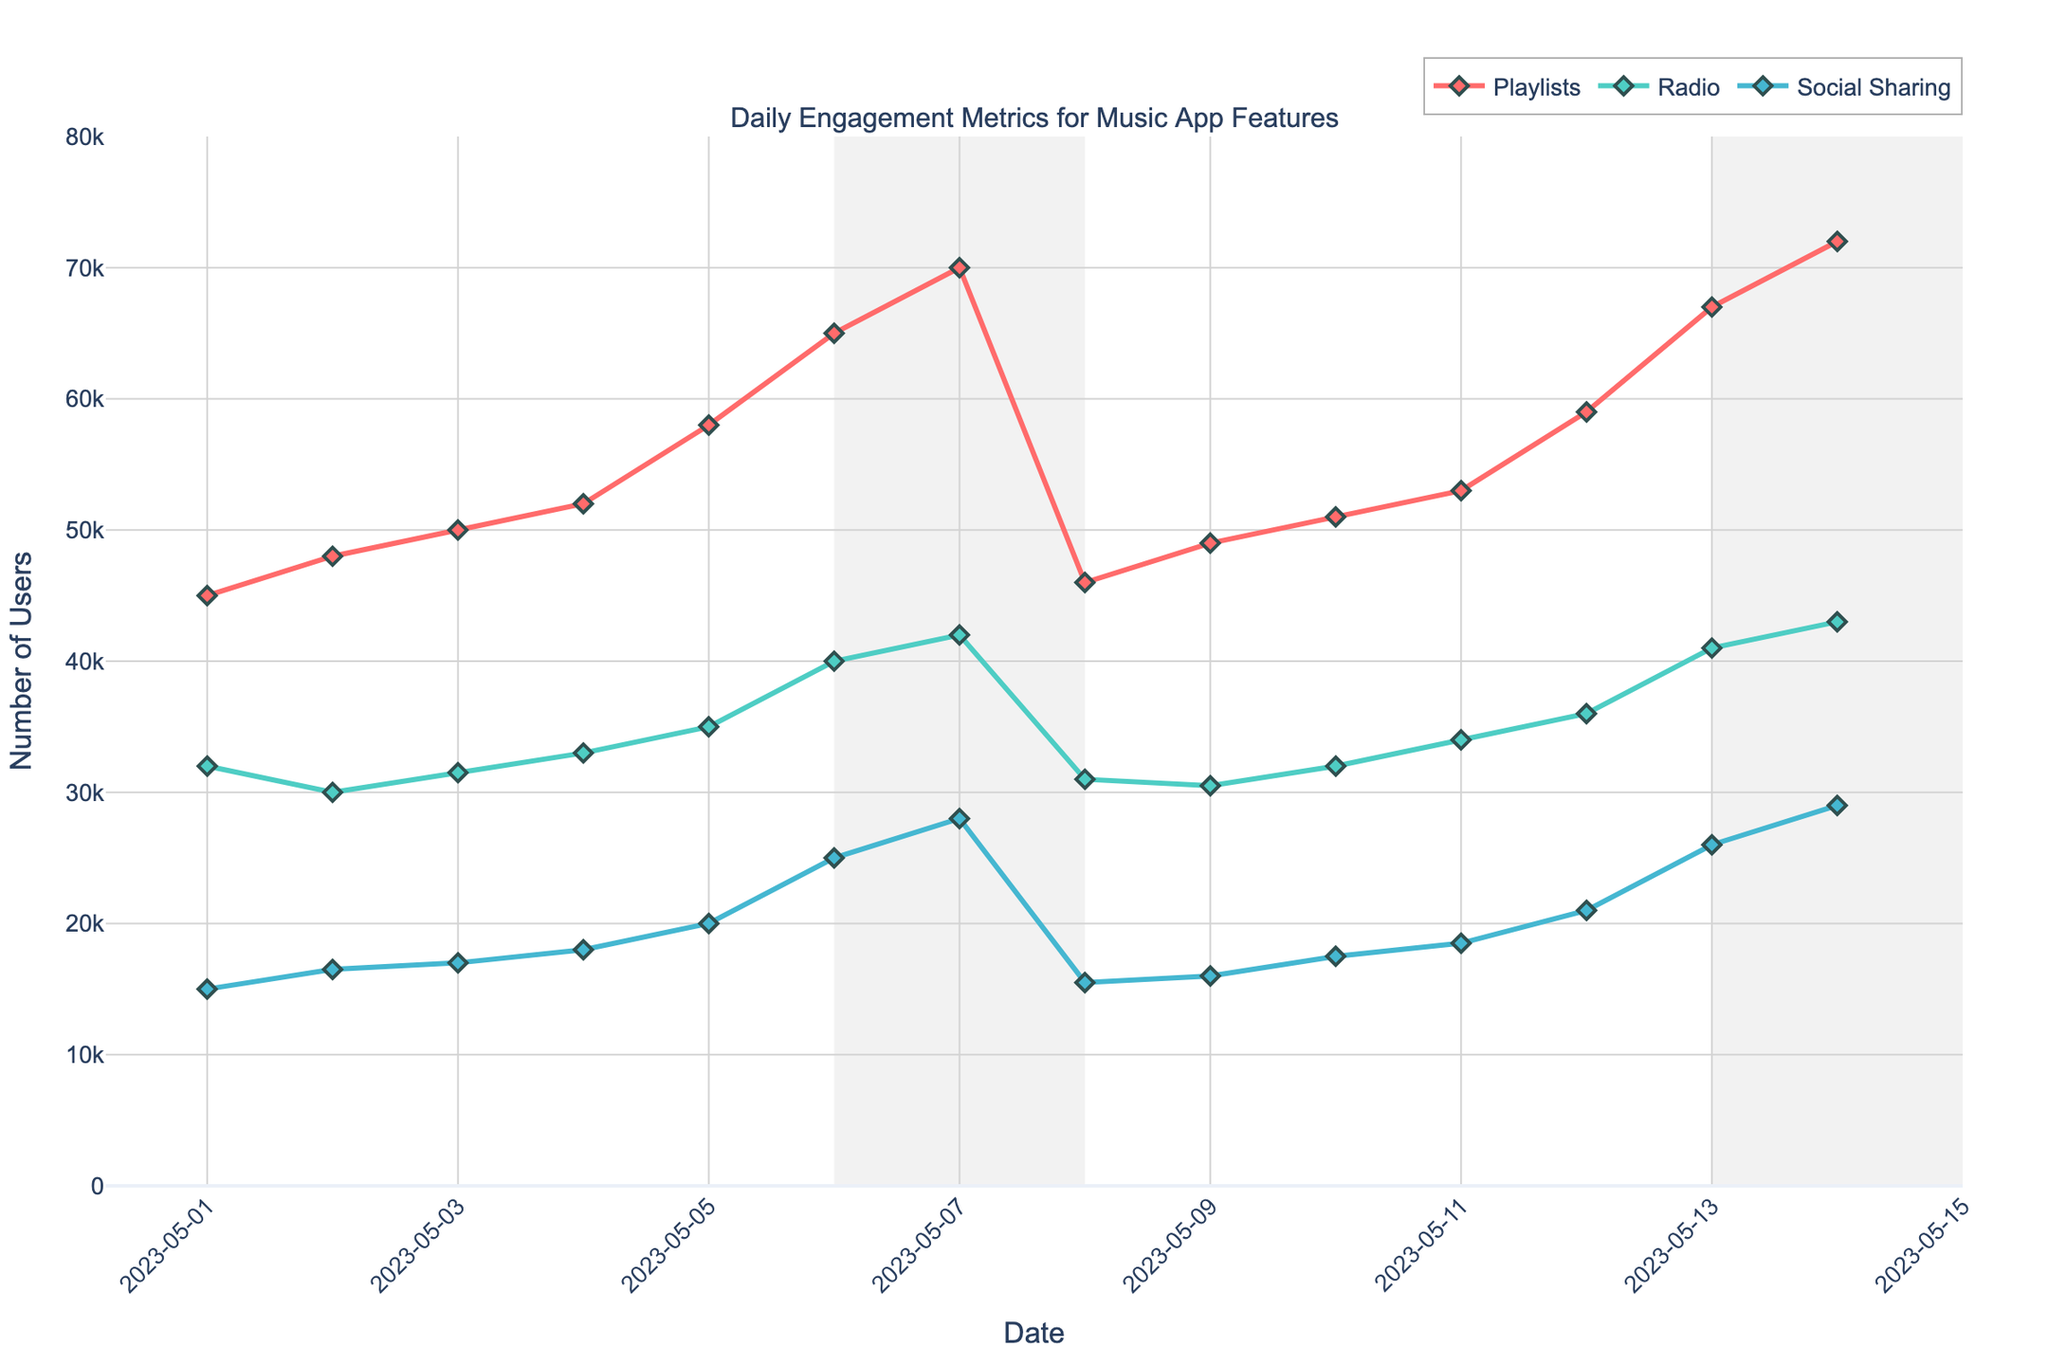what does the data reveal about user engagement with playlists over the weekends compared to weekdays? On weekends (highlighted areas), the number of users engaging with playlists (red line) is consistently higher compared to weekdays. For example, on May 6 and 7, there are 65000 and 70000 users respectively, whereas weekday numbers are consistently lower.
Answer: Higher on weekends What is the trend for social sharing feature usage from May 1 to May 7? The usage shows a steady increase over the week. Starting at 15000 users on May 1 and increasing daily to reach 28000 users on May 7.
Answer: Increasing Which feature had the lowest engagement on May 7? By comparing the points on May 7, the feature with the lowest number of users is Radio (green line) with 42000 users.
Answer: Radio During which days did the Radio feature see a consistent increase in usage? From the plot, Radio usage (green line) consistently increased from May 4 to May 7. May 4 had 33000 users and May 7 had 42000 users.
Answer: May 4 to May 7 Is there a noticeable drop in any feature's usage after the weekend? Yes, the Playlists feature (red line) shows a noticeable drop in user engagement from 70000 users on May 7 to 46000 on May 8.
Answer: Playlists How does social sharing’s peak usage day compare against playlists' peak usage day in number of users? On comparing the maximum points for social sharing and playlists, playlists peak at 72000 users on May 14 while social sharing peaks at 29000 users on the same day. The difference is 43000 users.
Answer: 43000 more users What is the average weekend (May 6 and 7) engagement for Radio? Adding the number of users for Radio on May 6 and 7 gives (40000 + 42000) = 82000, and the average is 82000 / 2 = 41000.
Answer: 41000 Compare the usage pattern of playlists and social sharing from May 1 to May 14. Both features show an increasing trend, but the growth rate of playlists is much steeper compared to social sharing. Playlists grow from 45000 to 72000 whereas social sharing grows from 15000 to 29000.
Answer: Playlists have a steeper growth Which feature shows the most fluctuation over the two weeks? By observing the lines for all features, Social Sharing (blue line) fluctuates the most, especially when compared to the more steadily increasing Radio (green line) and Playlists (red line).
Answer: Social Sharing 